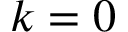<formula> <loc_0><loc_0><loc_500><loc_500>k = 0</formula> 